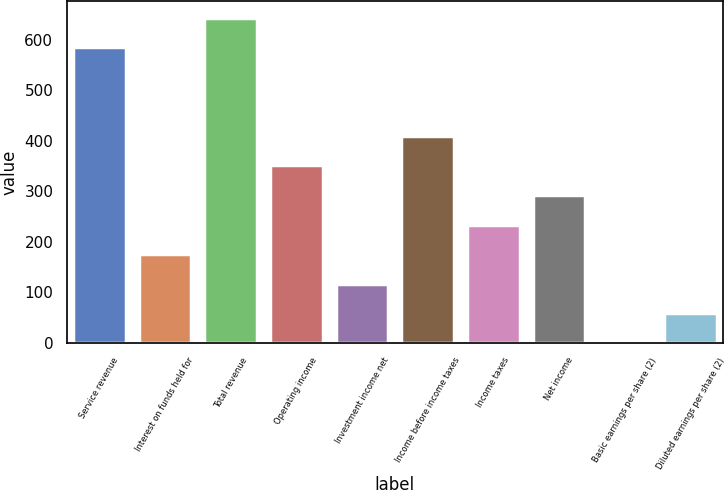Convert chart. <chart><loc_0><loc_0><loc_500><loc_500><bar_chart><fcel>Service revenue<fcel>Interest on funds held for<fcel>Total revenue<fcel>Operating income<fcel>Investment income net<fcel>Income before income taxes<fcel>Income taxes<fcel>Net income<fcel>Basic earnings per share (2)<fcel>Diluted earnings per share (2)<nl><fcel>585.34<fcel>175.84<fcel>643.84<fcel>351.34<fcel>117.34<fcel>409.84<fcel>234.34<fcel>292.84<fcel>0.34<fcel>58.84<nl></chart> 